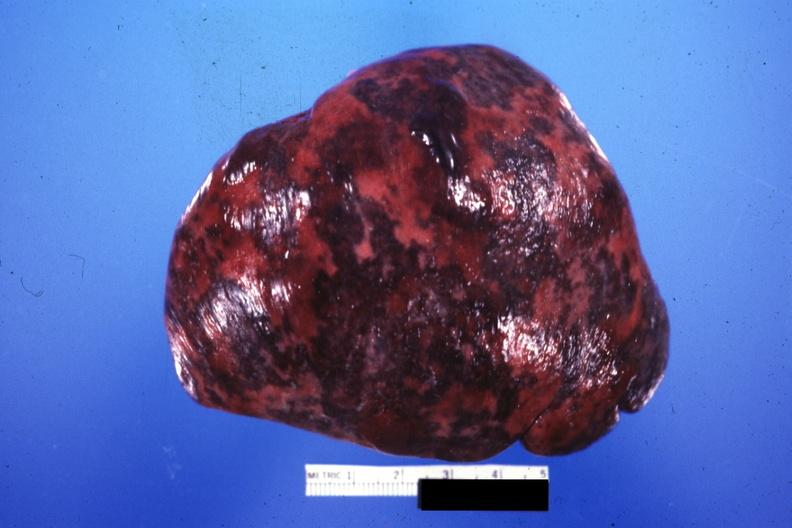where is this part in?
Answer the question using a single word or phrase. Spleen 